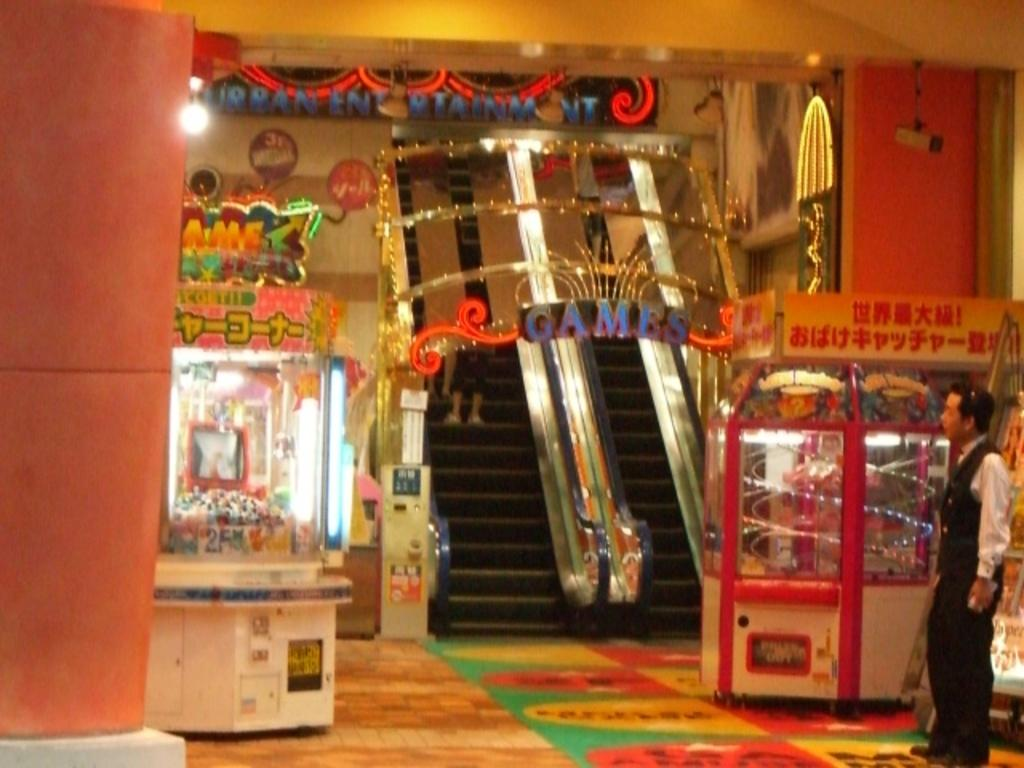What type of transportation is present in the image? There are two escalators in the image. What are the products/objects in the image contained within? The products/objects in the image are contained within glass boxes. Can you describe the person in the image? There is a man standing in the image. What type of decorative items can be seen in the image? There are decorative items in the image. Can you tell me how many rings are on the man's finger in the image? There is no information about rings or the man's fingers in the provided facts, so it cannot be determined from the image. Is there a tent visible in the image? There is no mention of a tent in the provided facts, and therefore it cannot be determined if one is present in the image. 